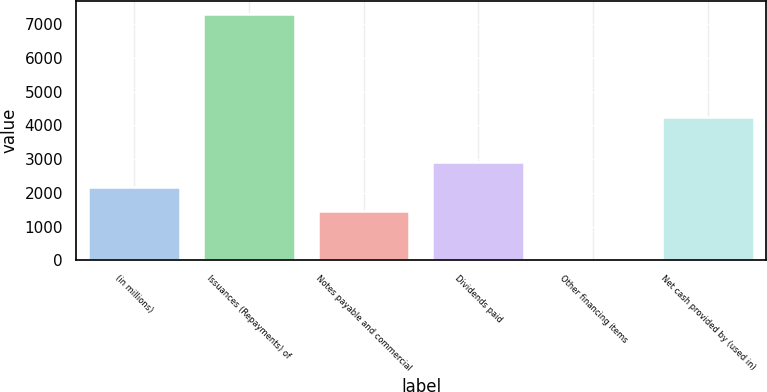Convert chart to OTSL. <chart><loc_0><loc_0><loc_500><loc_500><bar_chart><fcel>(in millions)<fcel>Issuances (Repayments) of<fcel>Notes payable and commercial<fcel>Dividends paid<fcel>Other financing items<fcel>Net cash provided by (used in)<nl><fcel>2176.9<fcel>7315<fcel>1447<fcel>2906.8<fcel>16<fcel>4251<nl></chart> 